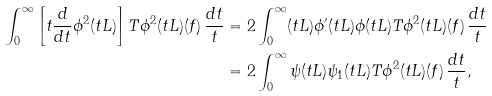<formula> <loc_0><loc_0><loc_500><loc_500>\int _ { 0 } ^ { \infty } \left [ t \frac { d } { d t } \phi ^ { 2 } ( t L ) \right ] T \phi ^ { 2 } ( t L ) ( f ) \, \frac { d t } { t } & = 2 \int _ { 0 } ^ { \infty } ( t L ) \phi ^ { \prime } ( t L ) \phi ( t L ) T \phi ^ { 2 } ( t L ) ( f ) \, \frac { d t } { t } \\ & = 2 \int _ { 0 } ^ { \infty } \psi ( t L ) \psi _ { 1 } ( t L ) T \phi ^ { 2 } ( t L ) ( f ) \, \frac { d t } { t } ,</formula> 